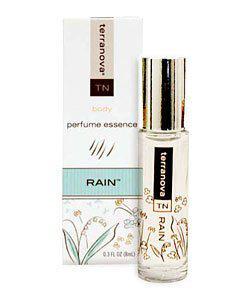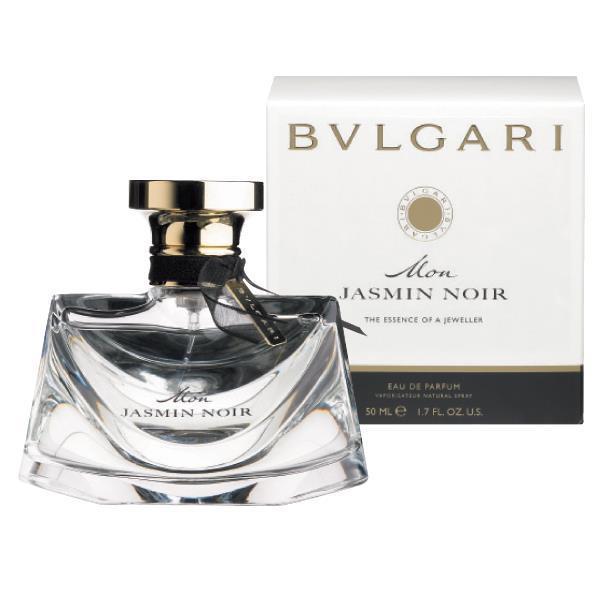The first image is the image on the left, the second image is the image on the right. For the images shown, is this caption "A perfume bottle is uncapped." true? Answer yes or no. No. 